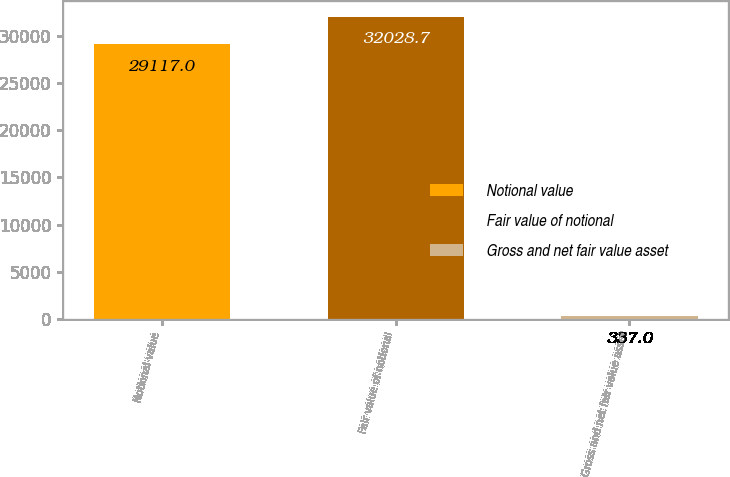Convert chart. <chart><loc_0><loc_0><loc_500><loc_500><bar_chart><fcel>Notional value<fcel>Fair value of notional<fcel>Gross and net fair value asset<nl><fcel>29117<fcel>32028.7<fcel>337<nl></chart> 